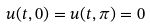Convert formula to latex. <formula><loc_0><loc_0><loc_500><loc_500>u ( t , 0 ) = u ( t , \pi ) = 0</formula> 